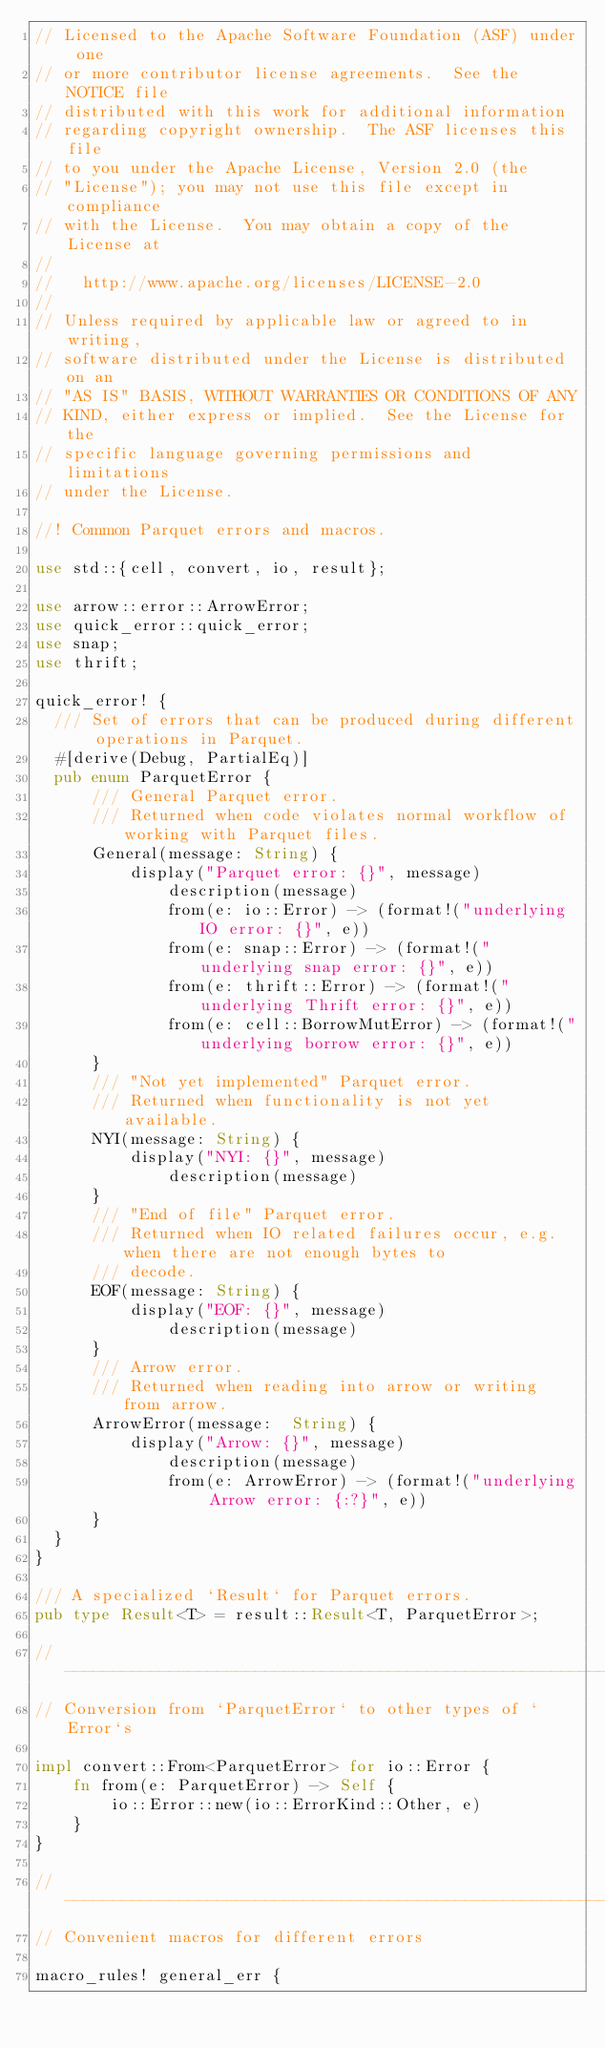Convert code to text. <code><loc_0><loc_0><loc_500><loc_500><_Rust_>// Licensed to the Apache Software Foundation (ASF) under one
// or more contributor license agreements.  See the NOTICE file
// distributed with this work for additional information
// regarding copyright ownership.  The ASF licenses this file
// to you under the Apache License, Version 2.0 (the
// "License"); you may not use this file except in compliance
// with the License.  You may obtain a copy of the License at
//
//   http://www.apache.org/licenses/LICENSE-2.0
//
// Unless required by applicable law or agreed to in writing,
// software distributed under the License is distributed on an
// "AS IS" BASIS, WITHOUT WARRANTIES OR CONDITIONS OF ANY
// KIND, either express or implied.  See the License for the
// specific language governing permissions and limitations
// under the License.

//! Common Parquet errors and macros.

use std::{cell, convert, io, result};

use arrow::error::ArrowError;
use quick_error::quick_error;
use snap;
use thrift;

quick_error! {
  /// Set of errors that can be produced during different operations in Parquet.
  #[derive(Debug, PartialEq)]
  pub enum ParquetError {
      /// General Parquet error.
      /// Returned when code violates normal workflow of working with Parquet files.
      General(message: String) {
          display("Parquet error: {}", message)
              description(message)
              from(e: io::Error) -> (format!("underlying IO error: {}", e))
              from(e: snap::Error) -> (format!("underlying snap error: {}", e))
              from(e: thrift::Error) -> (format!("underlying Thrift error: {}", e))
              from(e: cell::BorrowMutError) -> (format!("underlying borrow error: {}", e))
      }
      /// "Not yet implemented" Parquet error.
      /// Returned when functionality is not yet available.
      NYI(message: String) {
          display("NYI: {}", message)
              description(message)
      }
      /// "End of file" Parquet error.
      /// Returned when IO related failures occur, e.g. when there are not enough bytes to
      /// decode.
      EOF(message: String) {
          display("EOF: {}", message)
              description(message)
      }
      /// Arrow error.
      /// Returned when reading into arrow or writing from arrow.
      ArrowError(message:  String) {
          display("Arrow: {}", message)
              description(message)
              from(e: ArrowError) -> (format!("underlying Arrow error: {:?}", e))
      }
  }
}

/// A specialized `Result` for Parquet errors.
pub type Result<T> = result::Result<T, ParquetError>;

// ----------------------------------------------------------------------
// Conversion from `ParquetError` to other types of `Error`s

impl convert::From<ParquetError> for io::Error {
    fn from(e: ParquetError) -> Self {
        io::Error::new(io::ErrorKind::Other, e)
    }
}

// ----------------------------------------------------------------------
// Convenient macros for different errors

macro_rules! general_err {</code> 